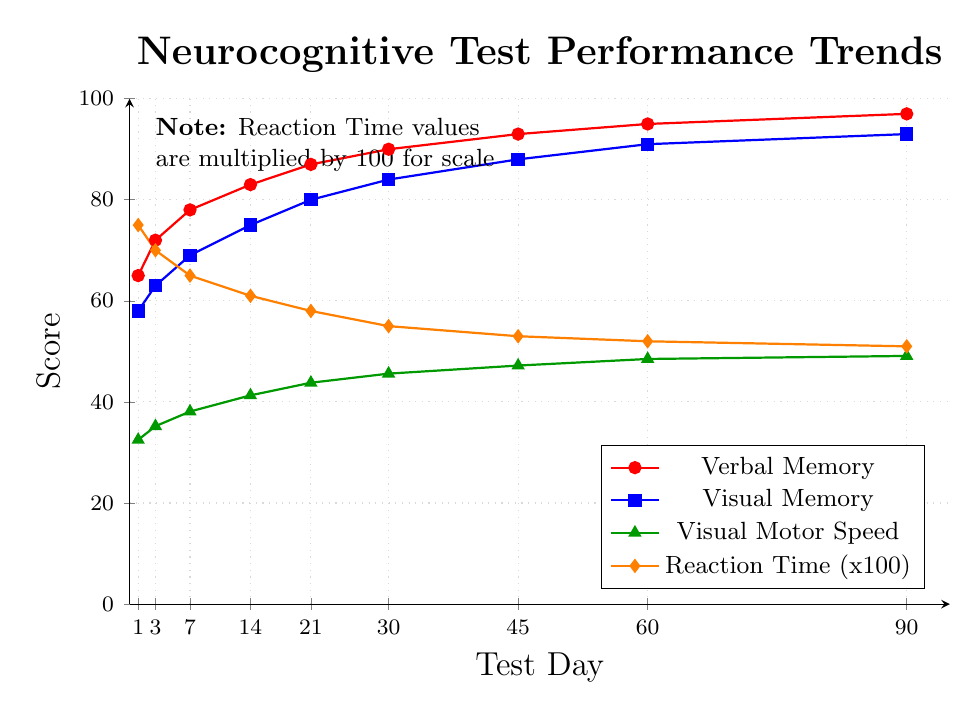What trend do we observe in the Verbal Memory score over time? The Verbal Memory scores start at 65 on Day 1 and gradually increase over time, reaching 97 by Day 90. This shows a consistent improvement.
Answer: Increasing trend On what day do Visual Memory scores surpass 80? The Visual Memory score reaches 80 on Day 21 as indicated by the data points on the chart.
Answer: Day 21 How much did Reaction Time improve from Day 1 to Day 90? Reaction Time starts at 0.75 on Day 1 and decreases to 0.51 by Day 90. The improvement is \(0.75 - 0.51 = 0.24\) seconds.
Answer: 0.24 seconds Compare the rate of improvement between Verbal Memory and Visual Motor Speed from Day 1 to Day 90. Which improves faster? Verbal Memory increases from 65 to 97, a change of 32 points over 90 days. Visual Motor Speed increases from 32.5 to 49.1, a change of 16.6 points. Verbal Memory improves faster.
Answer: Verbal Memory What is the average Verbal Memory score from Day 1 to Day 90? Sum the Verbal Memory scores: \(65 + 72 + 78 + 83 + 87 + 90 + 93 + 95 + 97 = 760\). There are 9 data points, so the average is \(760 / 9 = 84.4\).
Answer: 84.4 Which test score shows the least overall improvement from Day 1 to Day 90? Reaction Time improves by \(0.24\) seconds (from 0.75 to 0.51). Visually comparing this to increases in Verbal Memory (32 points), Visual Memory (35 points), and Visual Motor Speed (16.6 points), Reaction Time has the smallest improvement.
Answer: Reaction Time How does the Visual Memory score on Day 30 compare to the Visual Motor Speed score on Day 30? On Day 30, Visual Memory is 84, and Visual Motor Speed is 45.6. Visual Memory is significantly higher than Visual Motor Speed.
Answer: Visual Memory is higher What is the difference between Verbal Memory and Visual Memory on Day 45? Verbal Memory is 93 and Visual Memory is 88 on Day 45. The difference is \(93 - 88 = 5\).
Answer: 5 What color represents the Visual Motor Speed trend on the chart? The Visual Motor Speed trend is represented by a green line with triangular markers, as observed from the legend in the chart.
Answer: Green Between which two consecutive time points did Verbal Memory show the largest improvement? The largest improvement in Verbal Memory occurs between Day 1 and Day 3, with an increase of \(72 - 65 = 7\) points, which is larger than improvements between other consecutive time points.
Answer: Between Day 1 and Day 3 